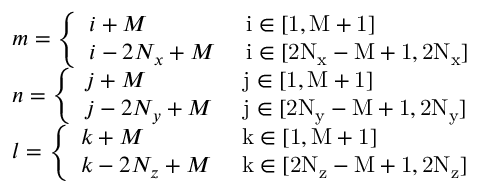Convert formula to latex. <formula><loc_0><loc_0><loc_500><loc_500>\begin{array} { r l } & { m = \left \{ \begin{array} { l l } { i + M } & { i \in [ 1 , M + 1 ] } \\ { i - 2 N _ { x } + M } & { i \in [ 2 N _ { x } - M + 1 , 2 N _ { x } ] } \end{array} } \\ & { n = \left \{ \begin{array} { l l } { j + M } & { j \in [ 1 , M + 1 ] } \\ { j - 2 N _ { y } + M } & { j \in [ 2 N _ { y } - M + 1 , 2 N _ { y } ] } \end{array} } \\ & { l = \left \{ \begin{array} { l l } { k + M } & { k \in [ 1 , M + 1 ] } \\ { k - 2 N _ { z } + M } & { k \in [ 2 N _ { z } - M + 1 , 2 N _ { z } ] } \end{array} } \end{array}</formula> 